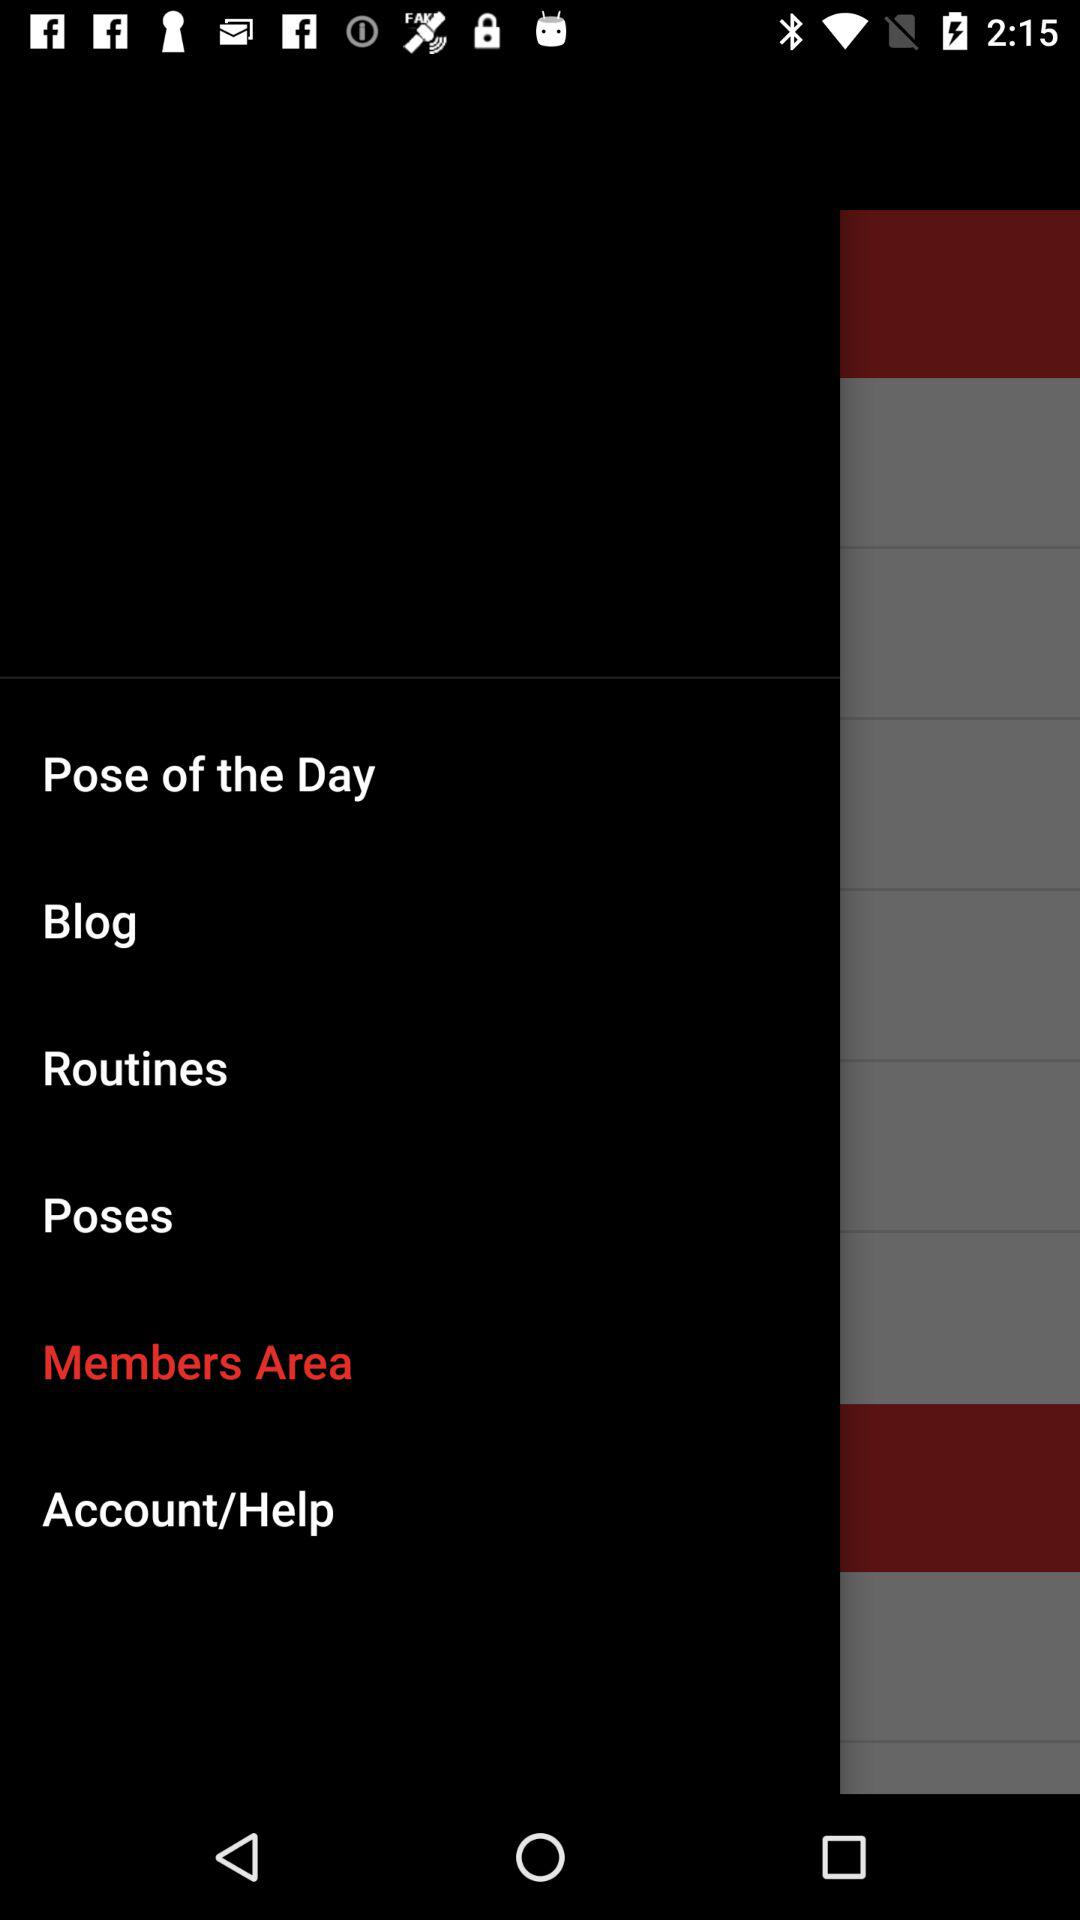What is the selected option? The selected option is "Members Area". 